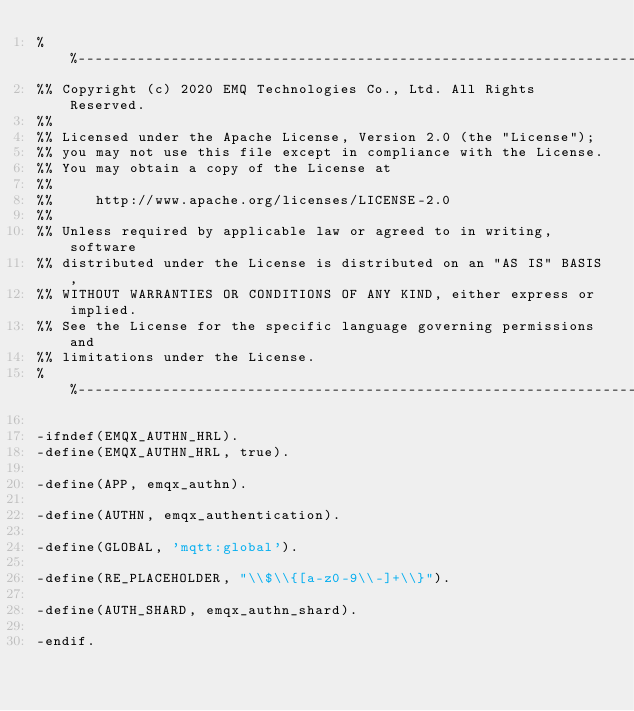<code> <loc_0><loc_0><loc_500><loc_500><_Erlang_>%%--------------------------------------------------------------------
%% Copyright (c) 2020 EMQ Technologies Co., Ltd. All Rights Reserved.
%%
%% Licensed under the Apache License, Version 2.0 (the "License");
%% you may not use this file except in compliance with the License.
%% You may obtain a copy of the License at
%%
%%     http://www.apache.org/licenses/LICENSE-2.0
%%
%% Unless required by applicable law or agreed to in writing, software
%% distributed under the License is distributed on an "AS IS" BASIS,
%% WITHOUT WARRANTIES OR CONDITIONS OF ANY KIND, either express or implied.
%% See the License for the specific language governing permissions and
%% limitations under the License.
%%--------------------------------------------------------------------

-ifndef(EMQX_AUTHN_HRL).
-define(EMQX_AUTHN_HRL, true).

-define(APP, emqx_authn).

-define(AUTHN, emqx_authentication).

-define(GLOBAL, 'mqtt:global').

-define(RE_PLACEHOLDER, "\\$\\{[a-z0-9\\-]+\\}").

-define(AUTH_SHARD, emqx_authn_shard).

-endif.
</code> 